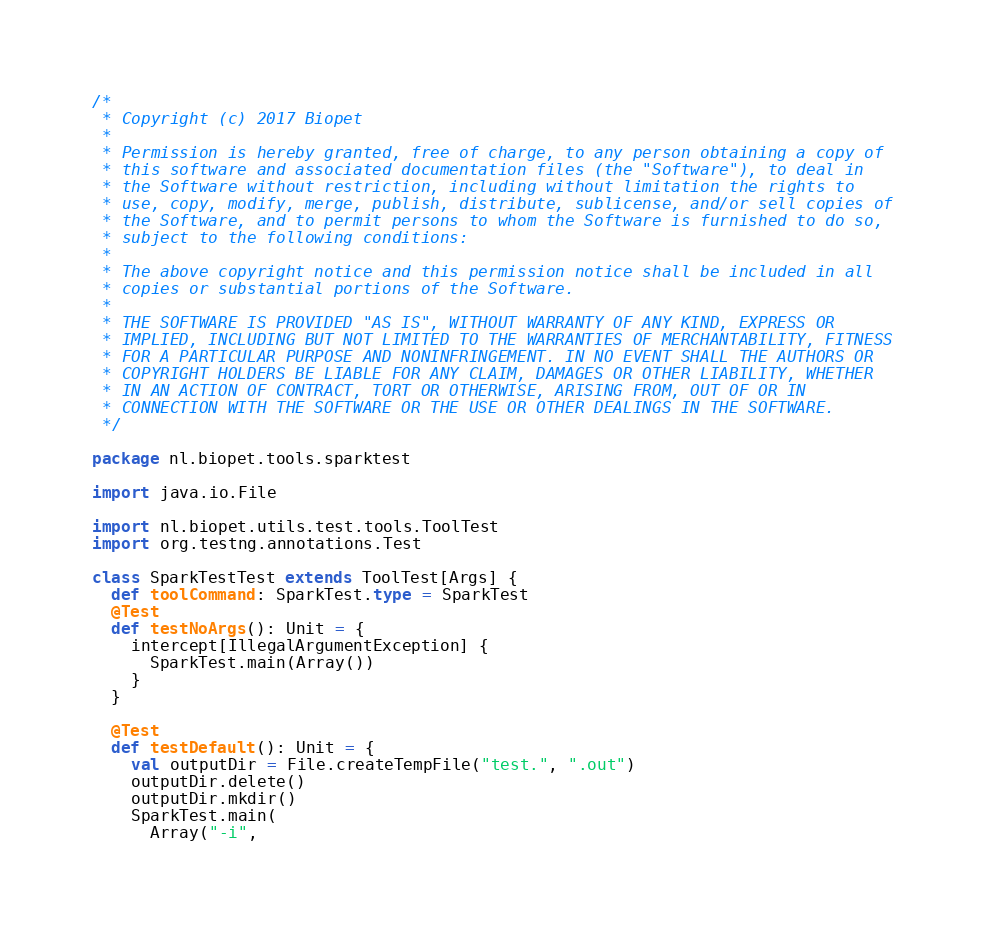Convert code to text. <code><loc_0><loc_0><loc_500><loc_500><_Scala_>/*
 * Copyright (c) 2017 Biopet
 *
 * Permission is hereby granted, free of charge, to any person obtaining a copy of
 * this software and associated documentation files (the "Software"), to deal in
 * the Software without restriction, including without limitation the rights to
 * use, copy, modify, merge, publish, distribute, sublicense, and/or sell copies of
 * the Software, and to permit persons to whom the Software is furnished to do so,
 * subject to the following conditions:
 *
 * The above copyright notice and this permission notice shall be included in all
 * copies or substantial portions of the Software.
 *
 * THE SOFTWARE IS PROVIDED "AS IS", WITHOUT WARRANTY OF ANY KIND, EXPRESS OR
 * IMPLIED, INCLUDING BUT NOT LIMITED TO THE WARRANTIES OF MERCHANTABILITY, FITNESS
 * FOR A PARTICULAR PURPOSE AND NONINFRINGEMENT. IN NO EVENT SHALL THE AUTHORS OR
 * COPYRIGHT HOLDERS BE LIABLE FOR ANY CLAIM, DAMAGES OR OTHER LIABILITY, WHETHER
 * IN AN ACTION OF CONTRACT, TORT OR OTHERWISE, ARISING FROM, OUT OF OR IN
 * CONNECTION WITH THE SOFTWARE OR THE USE OR OTHER DEALINGS IN THE SOFTWARE.
 */

package nl.biopet.tools.sparktest

import java.io.File

import nl.biopet.utils.test.tools.ToolTest
import org.testng.annotations.Test

class SparkTestTest extends ToolTest[Args] {
  def toolCommand: SparkTest.type = SparkTest
  @Test
  def testNoArgs(): Unit = {
    intercept[IllegalArgumentException] {
      SparkTest.main(Array())
    }
  }

  @Test
  def testDefault(): Unit = {
    val outputDir = File.createTempFile("test.", ".out")
    outputDir.delete()
    outputDir.mkdir()
    SparkTest.main(
      Array("-i",</code> 